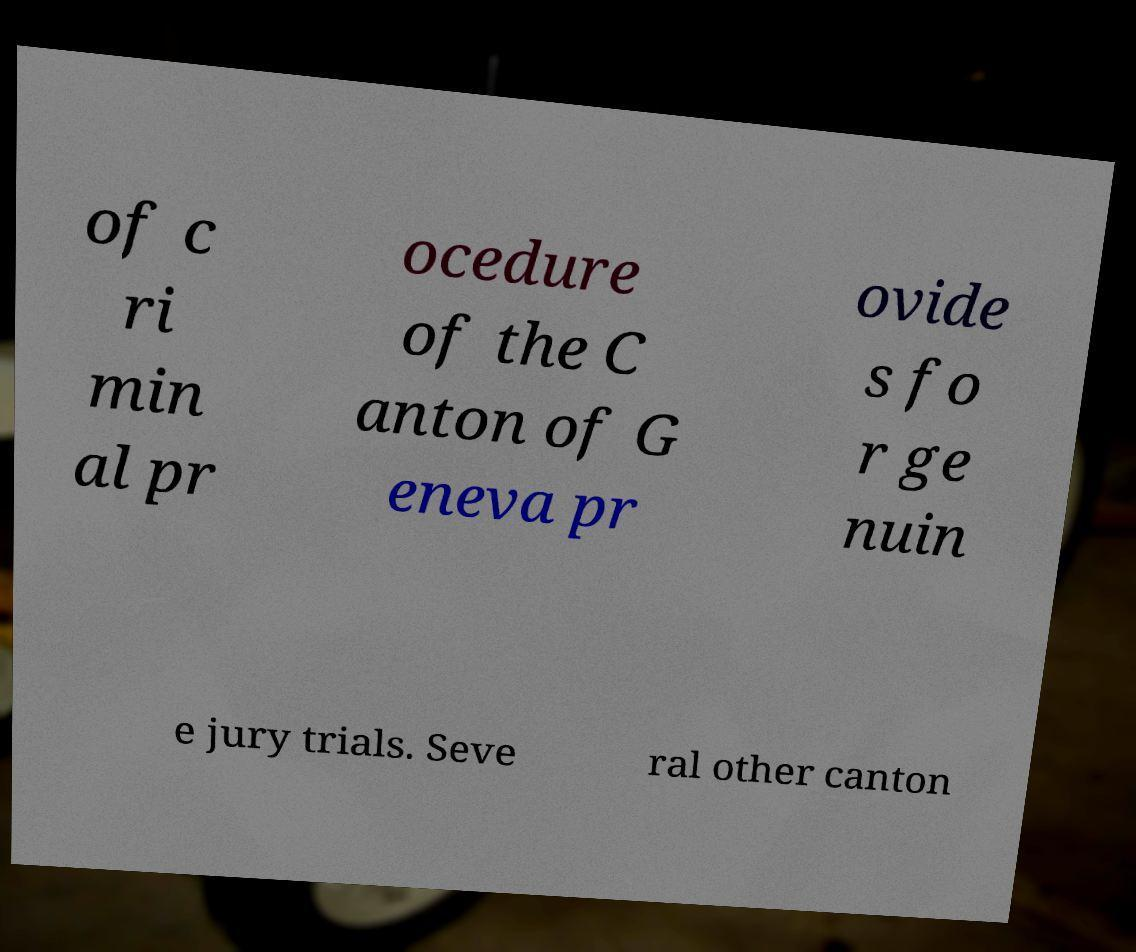Please read and relay the text visible in this image. What does it say? of c ri min al pr ocedure of the C anton of G eneva pr ovide s fo r ge nuin e jury trials. Seve ral other canton 